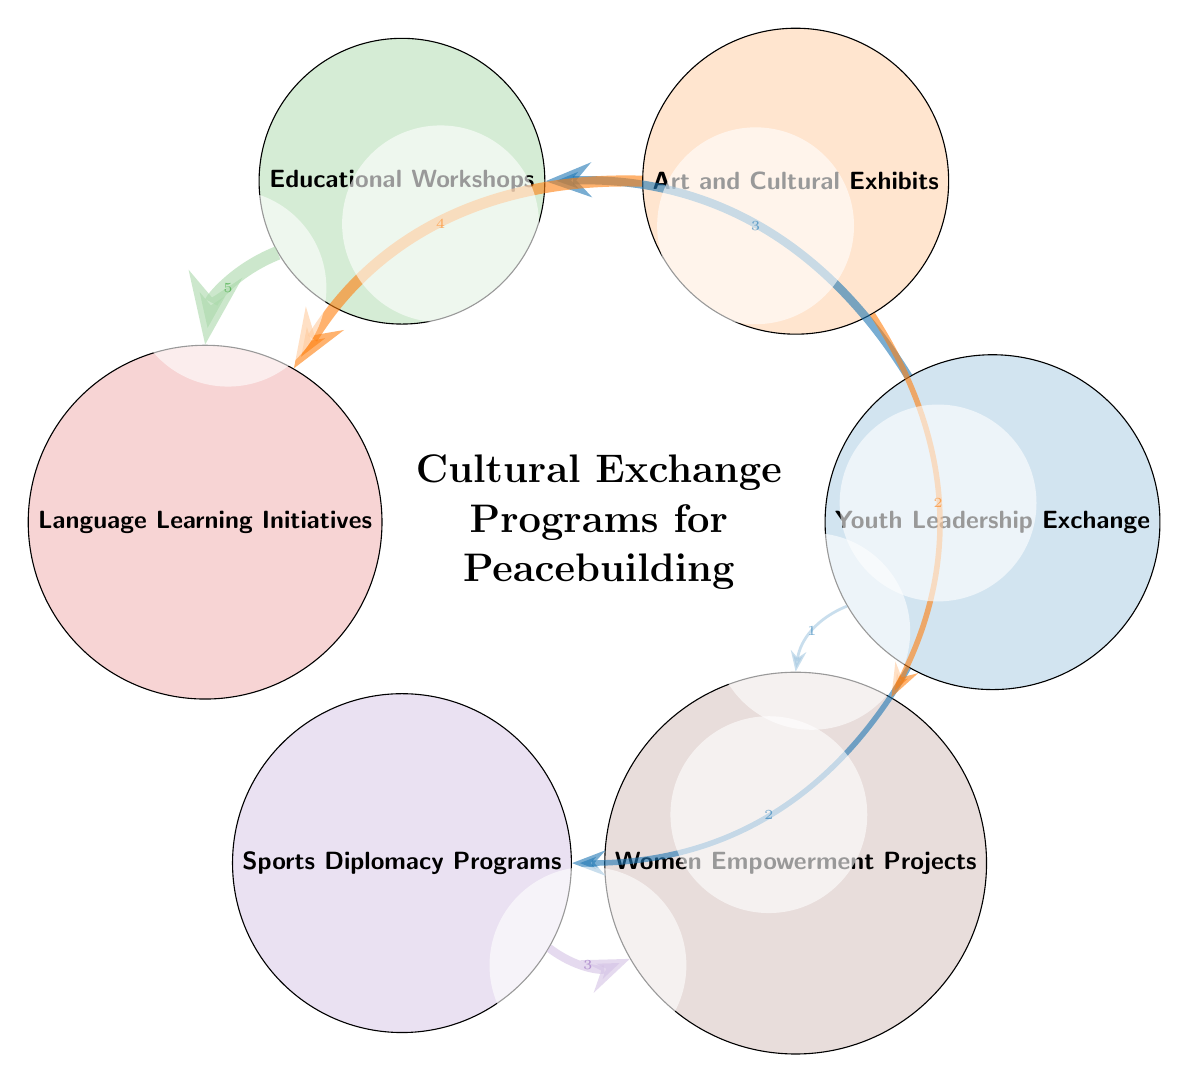What is the total number of nodes in the diagram? The diagram includes six different programs represented as nodes: Youth Leadership Exchange, Art and Cultural Exhibits, Educational Workshops, Language Learning Initiatives, Sports Diplomacy Programs, and Women Empowerment Projects. Counting these nodes gives a total of six.
Answer: 6 Which program has the strongest connection to Language Learning Initiatives? The Educational Workshops link to Language Learning Initiatives with the highest value of 5, indicating this is the strongest connection in the diagram.
Answer: Educational Workshops What is the value of the connection between Art and Cultural Exhibits and Women Empowerment Projects? The diagram shows that the connection from Art and Cultural Exhibits to Women Empowerment Projects has a value of 2. This represents the strength of the relationship between these two programs.
Answer: 2 How many connections does Youth Leadership Exchange have? Youth Leadership Exchange connects to three other programs: Educational Workshops, Sports Diplomacy Programs, and Women Empowerment Projects. Counting these connections gives a total of three.
Answer: 3 What is the weakest connection between the nodes in the diagram? The weakest connection can be identified by comparing the values of all links. The connection from Youth Leadership Exchange to Women Empowerment Projects has the lowest value of 1, indicating it's the weakest connection among the programs.
Answer: 1 Which program connects to both Women Empowerment Projects and Educational Workshops? Both Sports Diplomacy Programs and Youth Leadership Exchange connect to Women Empowerment Projects. However, only Educational Workshops connects specifically to Women Empowerment Projects through Youth Leadership Exchange, showing the interlinked nature of these programs.
Answer: Youth Leadership Exchange What percentage of the total connections does the strongest link represent? The strongest link is from Educational Workshops to Language Learning Initiatives with a value of 5. Counting all the values of connections gives a total of 17 (3+2+4+2+5+3+1). The percentage is then (5/17)*100, which is approximately 29.41%, showing its significance among the other connections.
Answer: 29.41% 